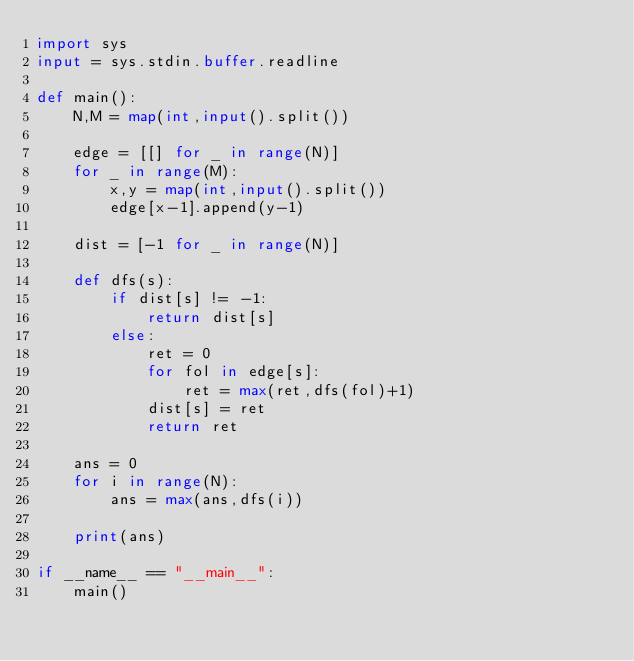<code> <loc_0><loc_0><loc_500><loc_500><_Python_>import sys
input = sys.stdin.buffer.readline

def main():
    N,M = map(int,input().split())
    
    edge = [[] for _ in range(N)]
    for _ in range(M):
        x,y = map(int,input().split())
        edge[x-1].append(y-1)
        
    dist = [-1 for _ in range(N)]
            
    def dfs(s):
        if dist[s] != -1:
            return dist[s]
        else:
            ret = 0
            for fol in edge[s]:
                ret = max(ret,dfs(fol)+1)
            dist[s] = ret
            return ret
    
    ans = 0    
    for i in range(N):
        ans = max(ans,dfs(i))
        
    print(ans)
        
if __name__ == "__main__":
    main()
</code> 